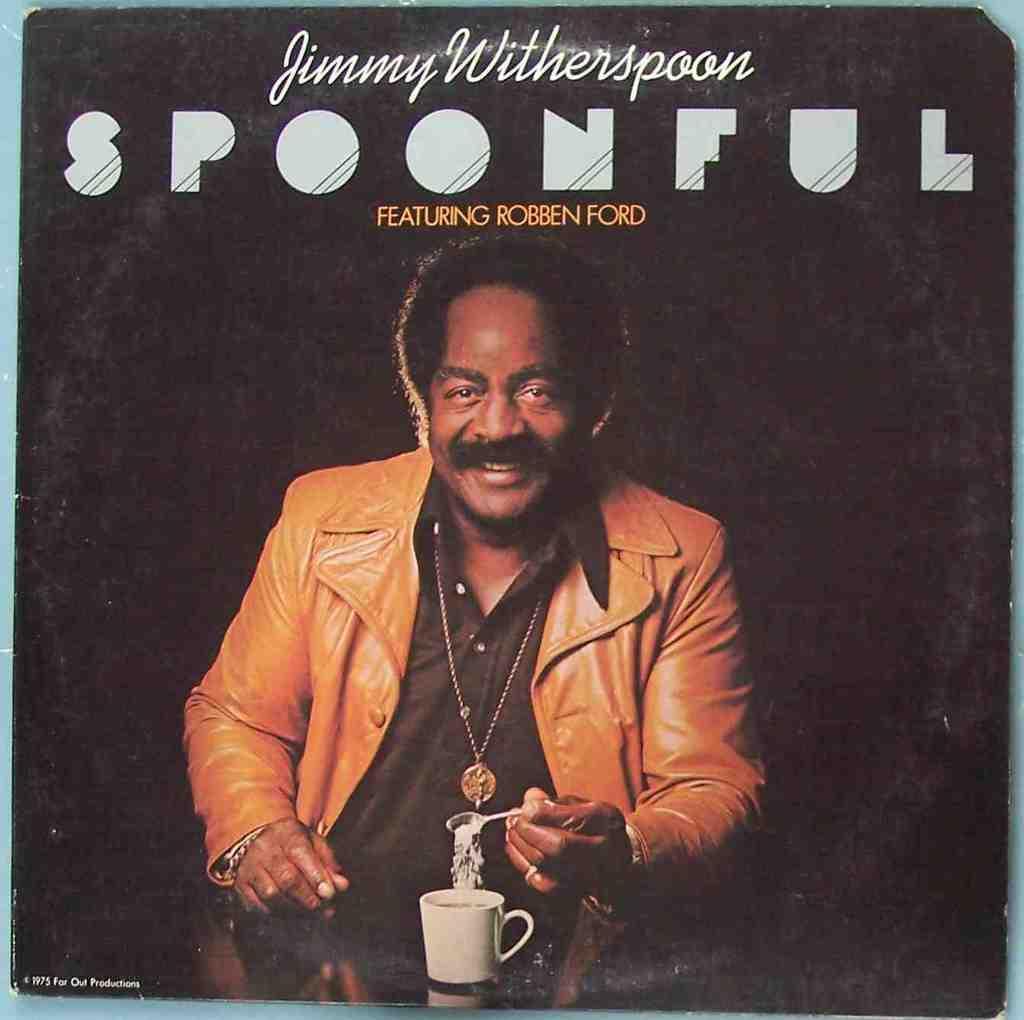Describe this image in one or two sentences. In this picture we can see a poster, on the poster, we can some text and image of a person holding a spoon and also we can see a cup. 